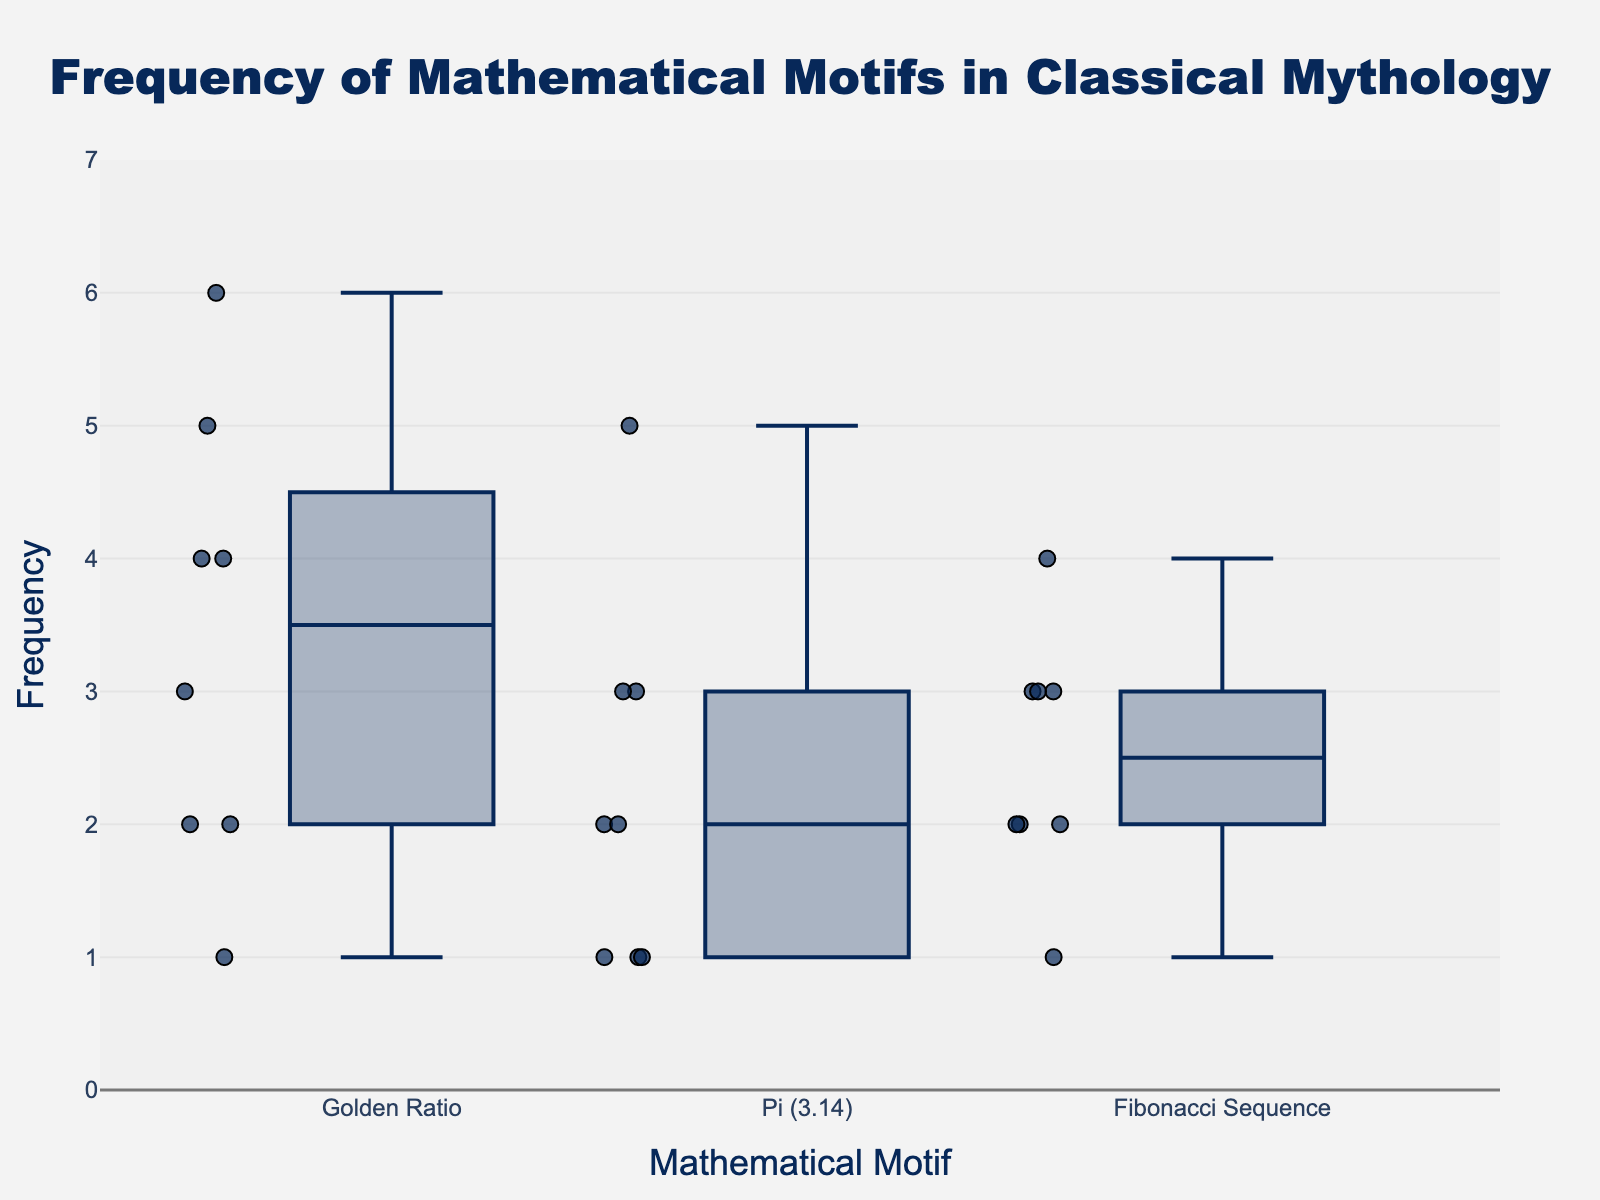What is the title of the box plot? The title is usually located at the top of the plot. In this case, it states "Frequency of Mathematical Motifs in Classical Mythology".
Answer: Frequency of Mathematical Motifs in Classical Mythology Which mathematical motif has the highest single-count frequency? Look at the scatter points to identify the motif with the highest point. The highest value, 6, is under the "Golden Ratio".
Answer: Golden Ratio What is the median frequency for the "Golden Ratio" motif? For the "Golden Ratio" box, the line inside the box represents the median. This value appears to be around 4.
Answer: 4 How do the counts of "Pi (3.14)" in Greek Myths and Hindu Myths compare? Locate the scatter points for "Pi (3.14)" and compare Greek Myths (3) and Hindu Myths (5). Hindu Myths have a higher count.
Answer: Hindu Myths have a higher count What range of frequencies does the "Fibonacci Sequence" motif cover? Check the y-axis for the highest and lowest points for the "Fibonacci Sequence". The range is from 1 to 4.
Answer: 1 to 4 What are the quartile values for the "Pi (3.14)" motif? Identify the "Pi (3.14)" box. The bottom edge of the box represents the first quartile (~1), the top edge the third quartile (~3), and the line inside the box the median (~2).
Answer: Q1: ~1, Q3: ~3, Median: ~2 Which motif shows the most consistency in its frequency? The box plot with the smallest range between its whiskers and few outliers shows consistency. "Pi (3.14)" seems to be the most consistent.
Answer: Pi (3.14) Between "Golden Ratio" and "Fibonacci Sequence," which motif has a higher median frequency? Comparing the medians inside the boxes, "Golden Ratio" has a median value of 4 while "Fibonacci Sequence" has a median of 3.
Answer: Golden Ratio How many mathematical motifs are plotted in the figure? Count the unique motif names listed on the x-axis. There are three: "Golden Ratio," "Pi (3.14)," and "Fibonacci Sequence".
Answer: 3 Which mythological source has the lowest frequency count for any motif? Identify the smallest scatter points across all motifs. Celtic Myths have the lowest with counts of (1) for all motifs.
Answer: Celtic Myths 